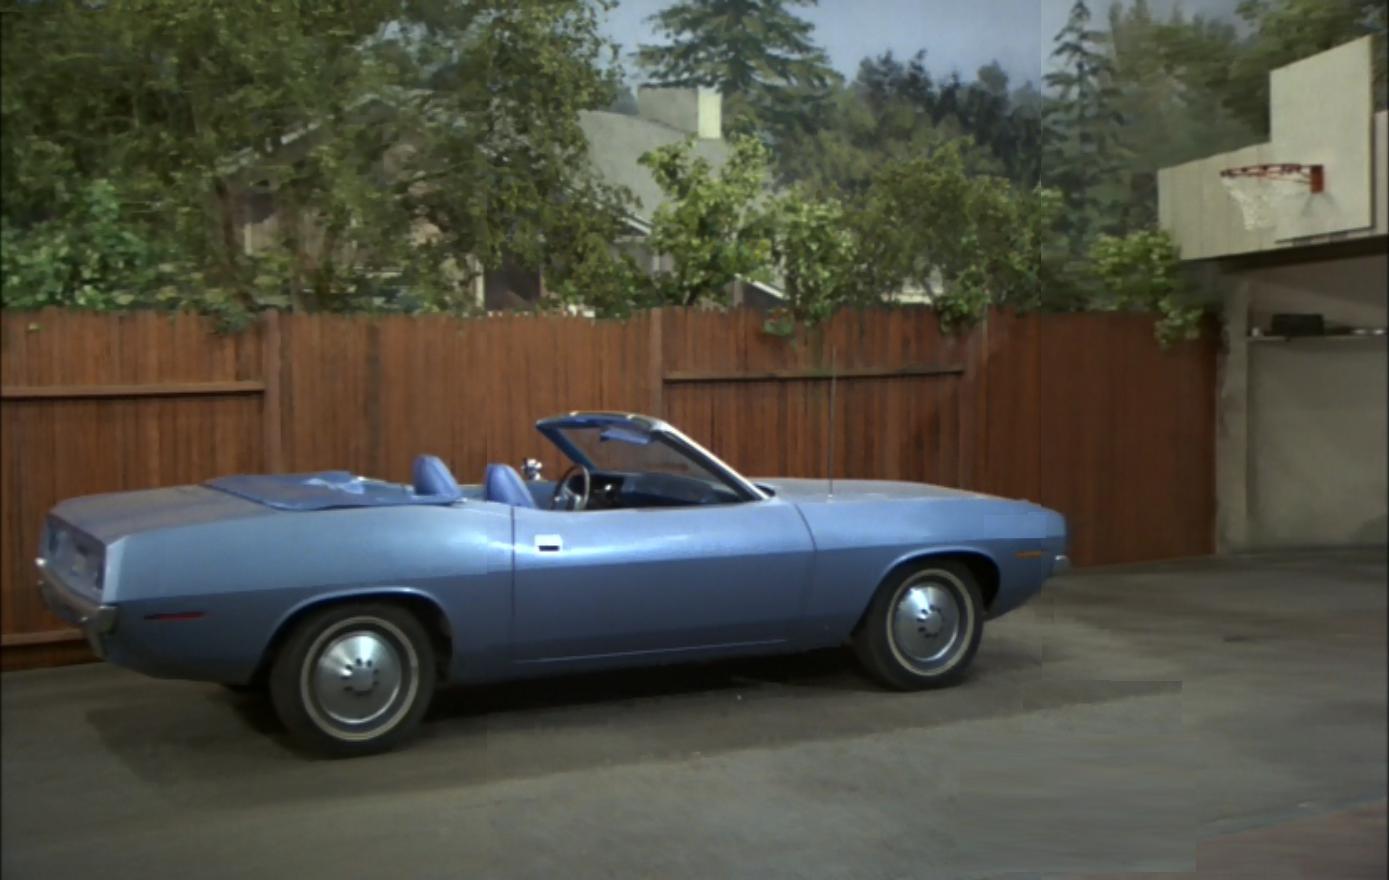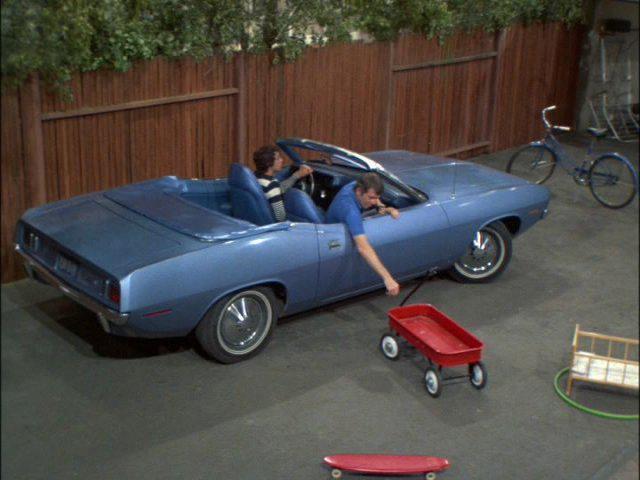The first image is the image on the left, the second image is the image on the right. For the images displayed, is the sentence "An image shows a young man behind the wheel of a powder blue convertible with top down." factually correct? Answer yes or no. Yes. The first image is the image on the left, the second image is the image on the right. Analyze the images presented: Is the assertion "Neither of the cars has a hood or roof on it." valid? Answer yes or no. Yes. The first image is the image on the left, the second image is the image on the right. Assess this claim about the two images: "Two cars have convertible tops and have small wing windows beside the windshield.". Correct or not? Answer yes or no. No. The first image is the image on the left, the second image is the image on the right. For the images displayed, is the sentence "An image shows at least two people in a blue convertible with the top down, next to a privacy fence." factually correct? Answer yes or no. Yes. 